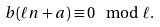Convert formula to latex. <formula><loc_0><loc_0><loc_500><loc_500>b ( \ell n + a ) \equiv 0 \mod \ell .</formula> 